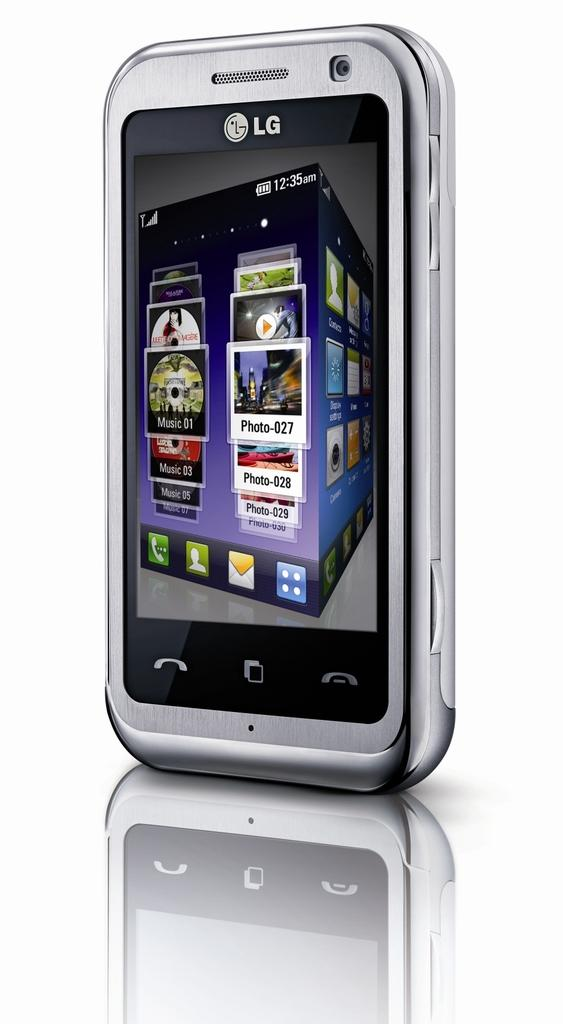<image>
Write a terse but informative summary of the picture. a series of photos with one that has 027 on it 